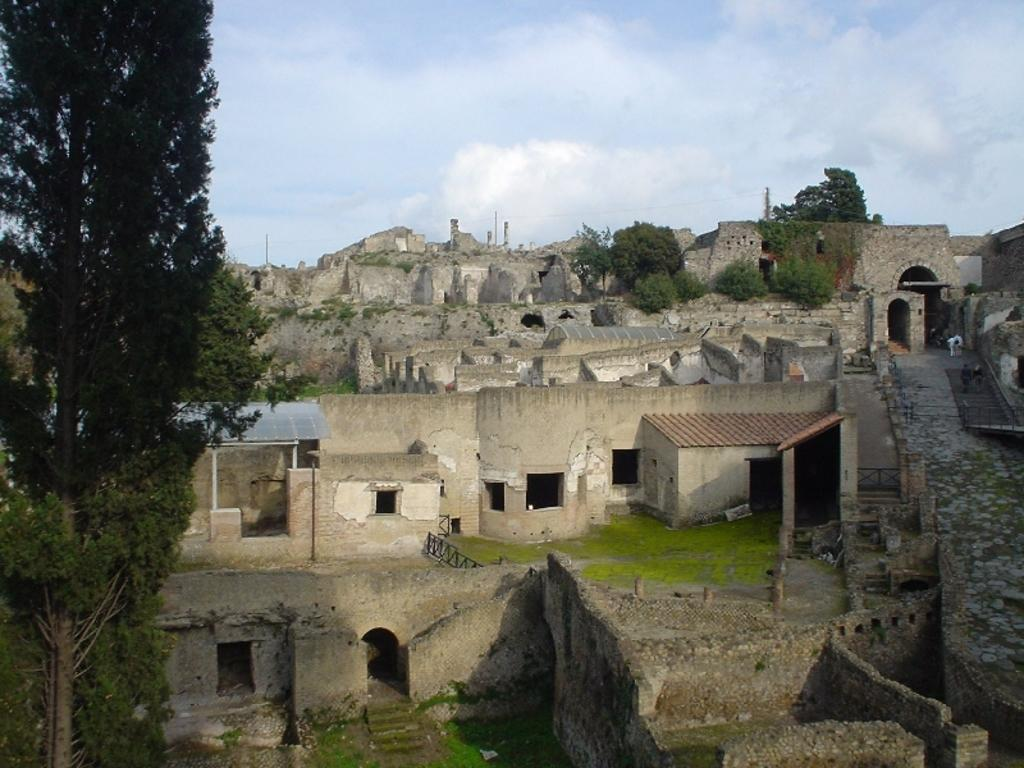What type of structure is shown in the image? The image depicts a fort. What type of vegetation is present in the image? There is grass in the image. What type of barrier can be seen in the image? There is a fence in the image. Are there any living beings in the image? Yes, there are people in the image. What type of natural elements are present in the image? There are trees in the image. How would you describe the weather in the image? The sky is cloudy in the image. What type of vehicle can be seen driving through the fort in the image? There is no vehicle present in the image, and no driving is taking place. What type of industrial machinery can be seen in the image? There is no industrial machinery present in the image. What type of beverage is being served in the image? There is no beverage present in the image, and no serving is taking place. 